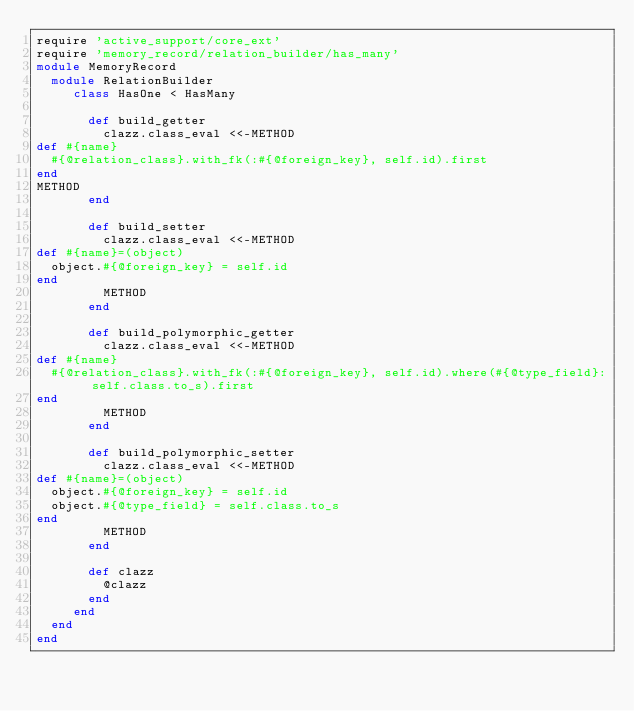Convert code to text. <code><loc_0><loc_0><loc_500><loc_500><_Ruby_>require 'active_support/core_ext'
require 'memory_record/relation_builder/has_many'
module MemoryRecord
  module RelationBuilder
     class HasOne < HasMany

       def build_getter
         clazz.class_eval <<-METHOD
def #{name}
  #{@relation_class}.with_fk(:#{@foreign_key}, self.id).first
end
METHOD
       end

       def build_setter
         clazz.class_eval <<-METHOD
def #{name}=(object)
  object.#{@foreign_key} = self.id
end
         METHOD
       end

       def build_polymorphic_getter
         clazz.class_eval <<-METHOD
def #{name}
  #{@relation_class}.with_fk(:#{@foreign_key}, self.id).where(#{@type_field}: self.class.to_s).first
end
         METHOD
       end

       def build_polymorphic_setter
         clazz.class_eval <<-METHOD
def #{name}=(object)
  object.#{@foreign_key} = self.id
  object.#{@type_field} = self.class.to_s
end
         METHOD
       end

       def clazz
         @clazz
       end
     end
  end
end
</code> 